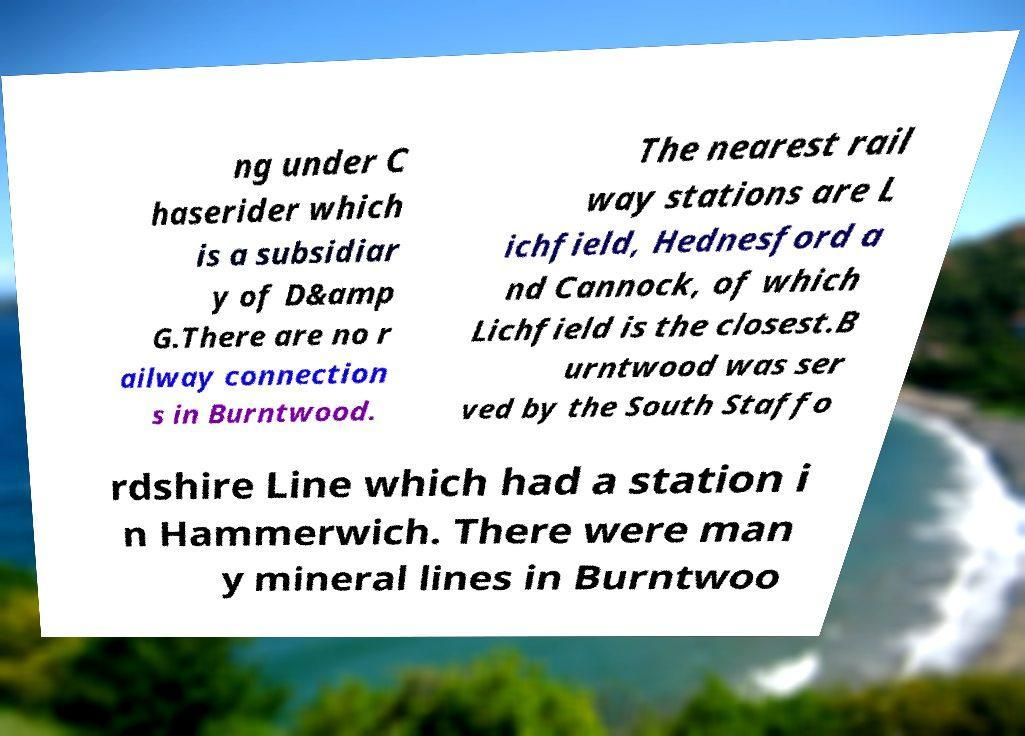Could you assist in decoding the text presented in this image and type it out clearly? ng under C haserider which is a subsidiar y of D&amp G.There are no r ailway connection s in Burntwood. The nearest rail way stations are L ichfield, Hednesford a nd Cannock, of which Lichfield is the closest.B urntwood was ser ved by the South Staffo rdshire Line which had a station i n Hammerwich. There were man y mineral lines in Burntwoo 